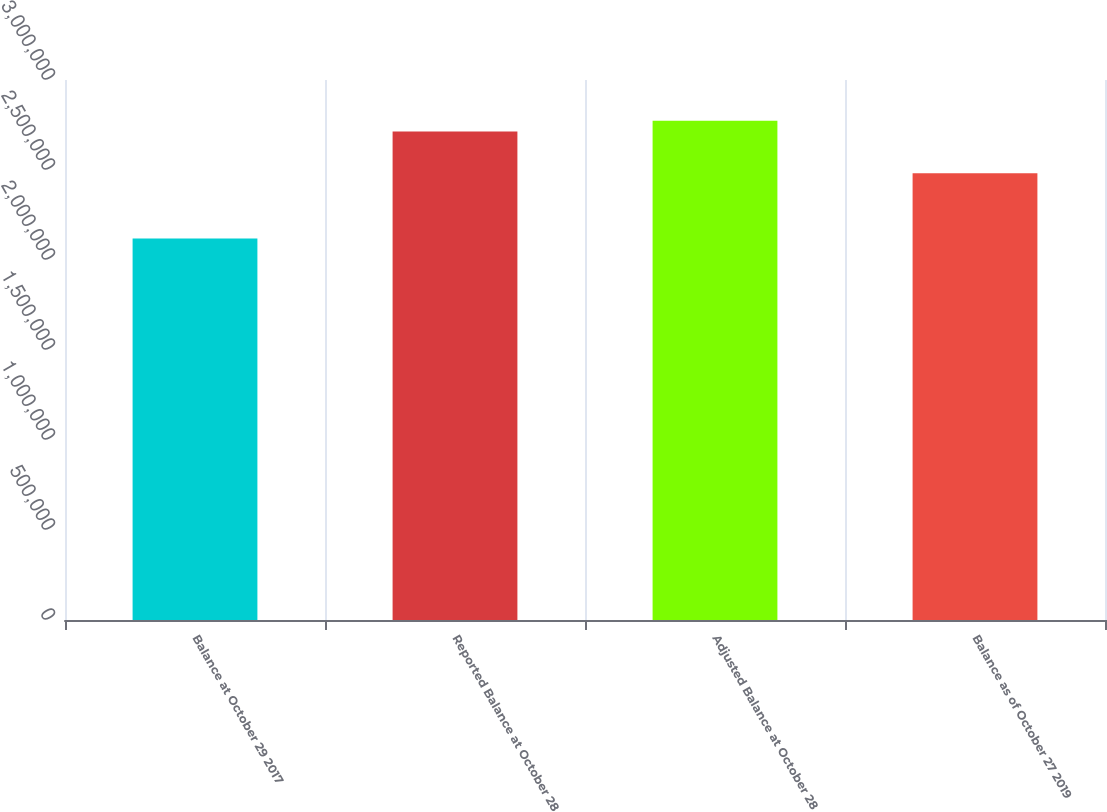Convert chart to OTSL. <chart><loc_0><loc_0><loc_500><loc_500><bar_chart><fcel>Balance at October 29 2017<fcel>Reported Balance at October 28<fcel>Adjusted Balance at October 28<fcel>Balance as of October 27 2019<nl><fcel>2.11981e+06<fcel>2.71412e+06<fcel>2.77355e+06<fcel>2.48164e+06<nl></chart> 